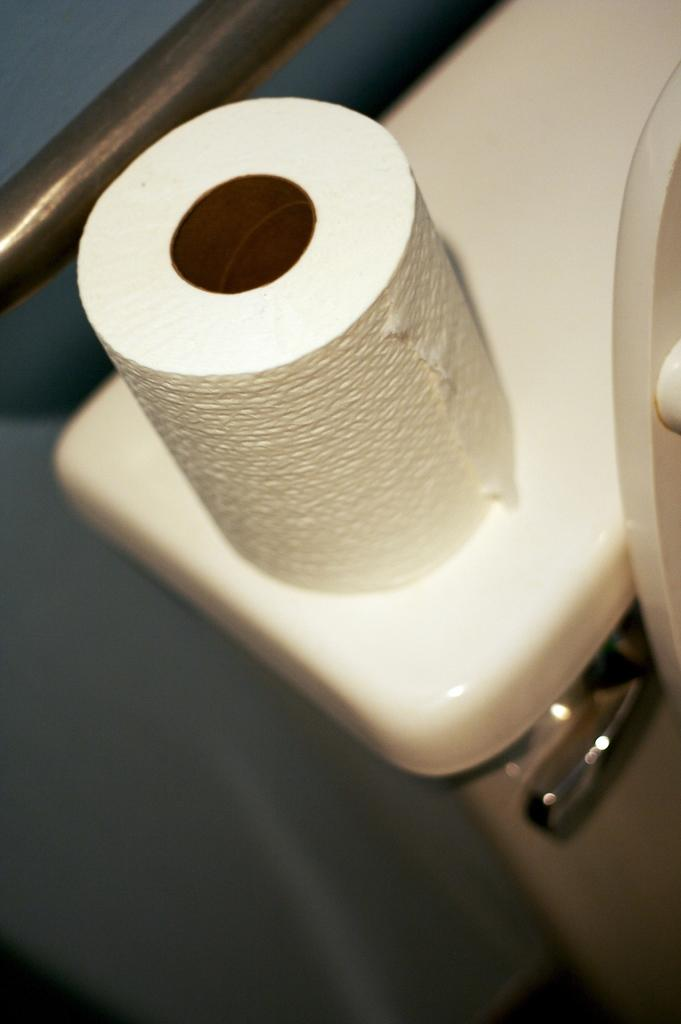What is the main object in the image? There is a tissue paper roll in the image. Where is the tissue paper roll located? The tissue paper roll is on an object that looks like a toilet. What grade does the park receive for its cleanliness in the image? There is no park present in the image, so it is not possible to evaluate its cleanliness or assign a grade. 